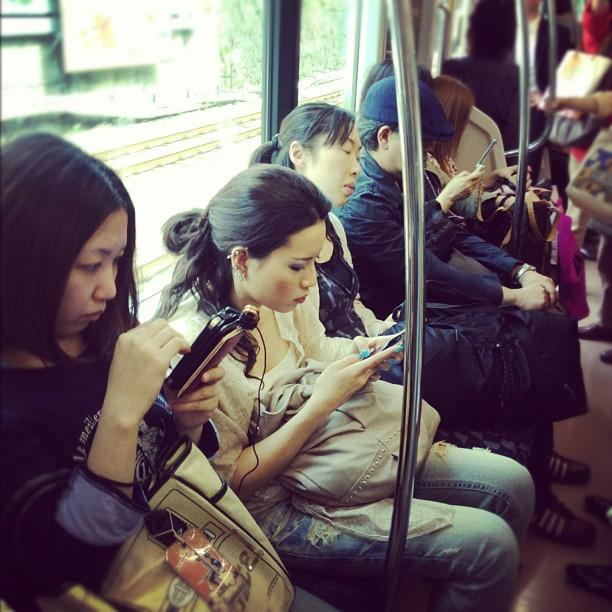If one was standing what would assist in maintaining their balance?

Choices:
A) chair
B) phone
C) window
D) pole pole 